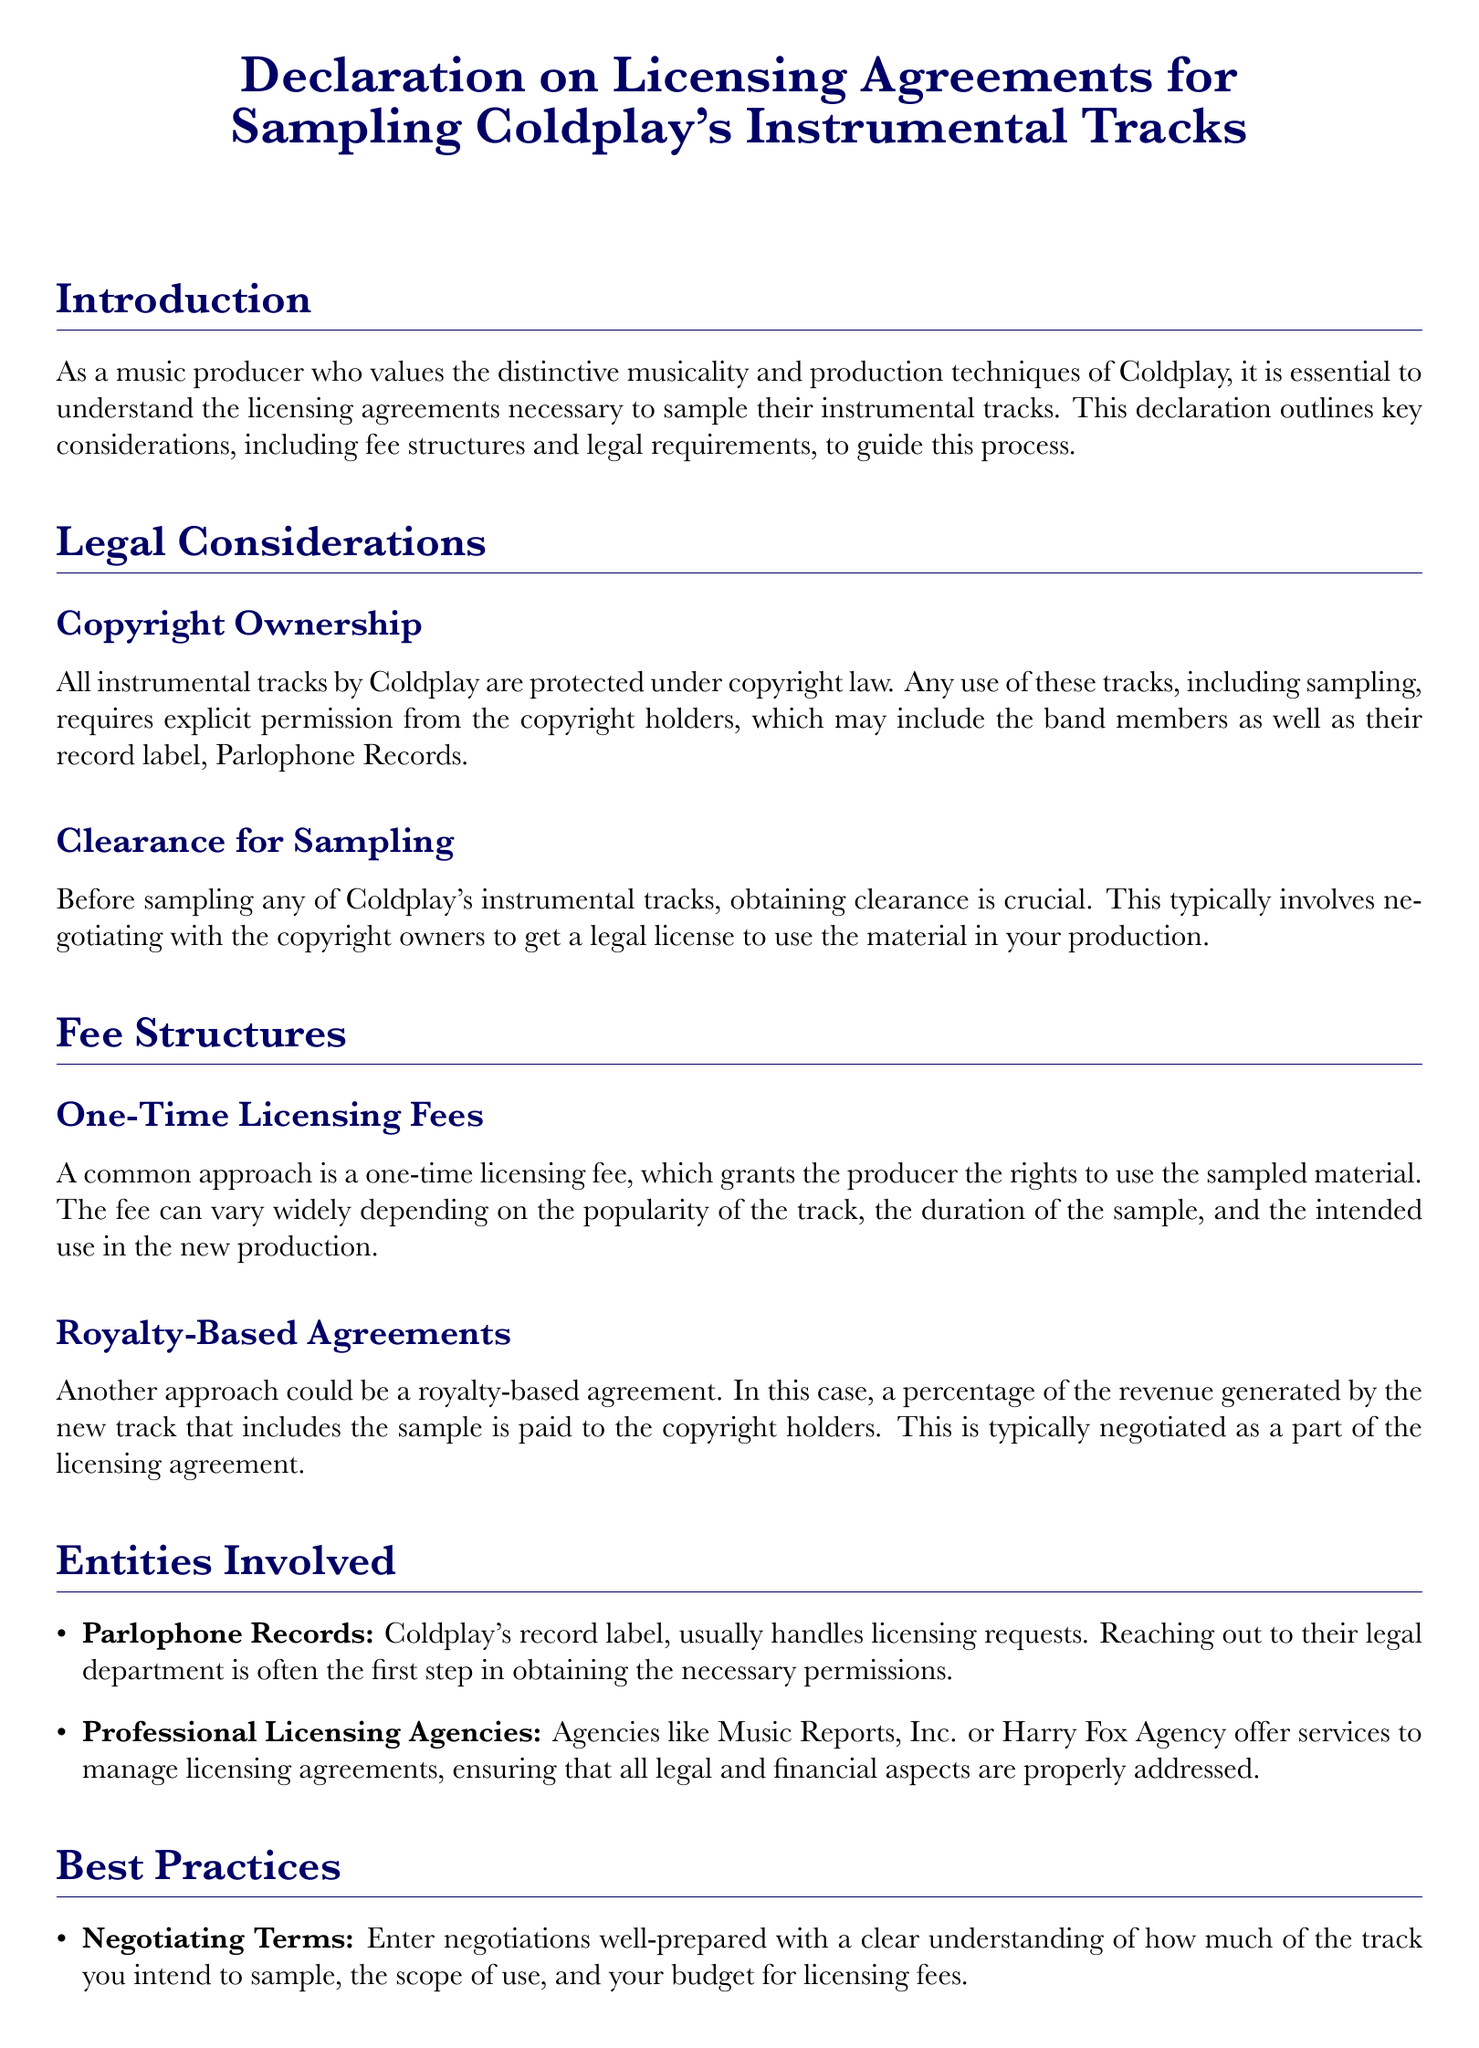What is the title of the document? The title is the main heading which provides the subject of the declaration, clearly stated in the document.
Answer: Declaration on Licensing Agreements for Sampling Coldplay's Instrumental Tracks Who holds the copyright for Coldplay's instrumental tracks? The copyright ownership involves the band members as well as their record label, indicating who needs to be contacted for permissions.
Answer: Copyright holders What are two structures for licensing fees mentioned? The document outlines two types of fee structures, which are essential for understanding payments related to sampling.
Answer: One-Time Licensing Fees, Royalty-Based Agreements Which record label is associated with Coldplay? This information identifies the organization responsible for managing Coldplay's music and related licensing issues.
Answer: Parlophone Records What should be engaged for legal counsel in licensing agreements? This recommendation highlights the importance of legal expertise when dealing with music licensing, ensuring compliance and proper terms.
Answer: Legal expert What is one of the best practices suggested for negotiating terms? A specific action is recommended in the document that helps producers be better prepared during negotiations for licensing agreements.
Answer: Enter negotiations well-prepared What is necessary before sampling Coldplay's tracks? This knowledge is vital for producers to understand the legalities involved in using the tracks and ensures compliance with copyright laws.
Answer: Obtaining clearance What type of agencies can manage licensing agreements? The document mentions specific entities that can assist with the legal and financial aspects of licensing, helping streamline the process for producers.
Answer: Professional Licensing Agencies What does a royalty-based agreement entail? Understanding this type of agreement is important for recognizing the potential financial commitments when sampling songs.
Answer: A percentage of the revenue generated 